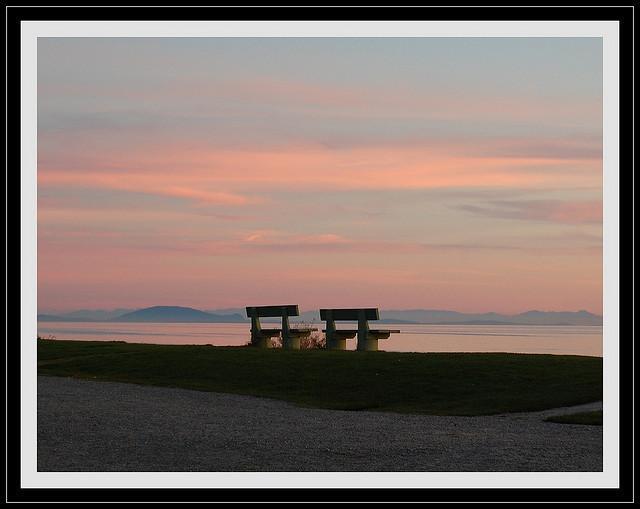How many benches are photographed?
Give a very brief answer. 2. How many benches can you see?
Give a very brief answer. 2. How many people are leaning against a wall?
Give a very brief answer. 0. 